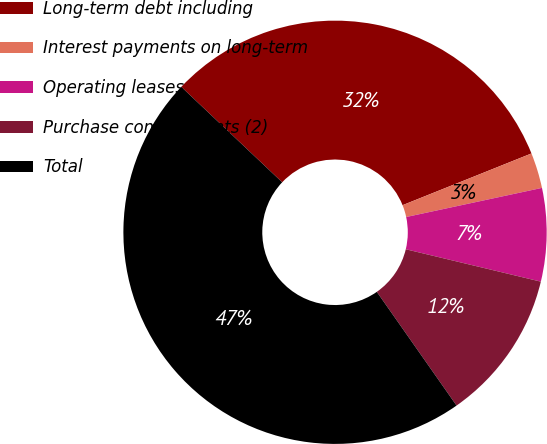<chart> <loc_0><loc_0><loc_500><loc_500><pie_chart><fcel>Long-term debt including<fcel>Interest payments on long-term<fcel>Operating leases<fcel>Purchase commitments (2)<fcel>Total<nl><fcel>31.87%<fcel>2.71%<fcel>7.11%<fcel>11.52%<fcel>46.79%<nl></chart> 